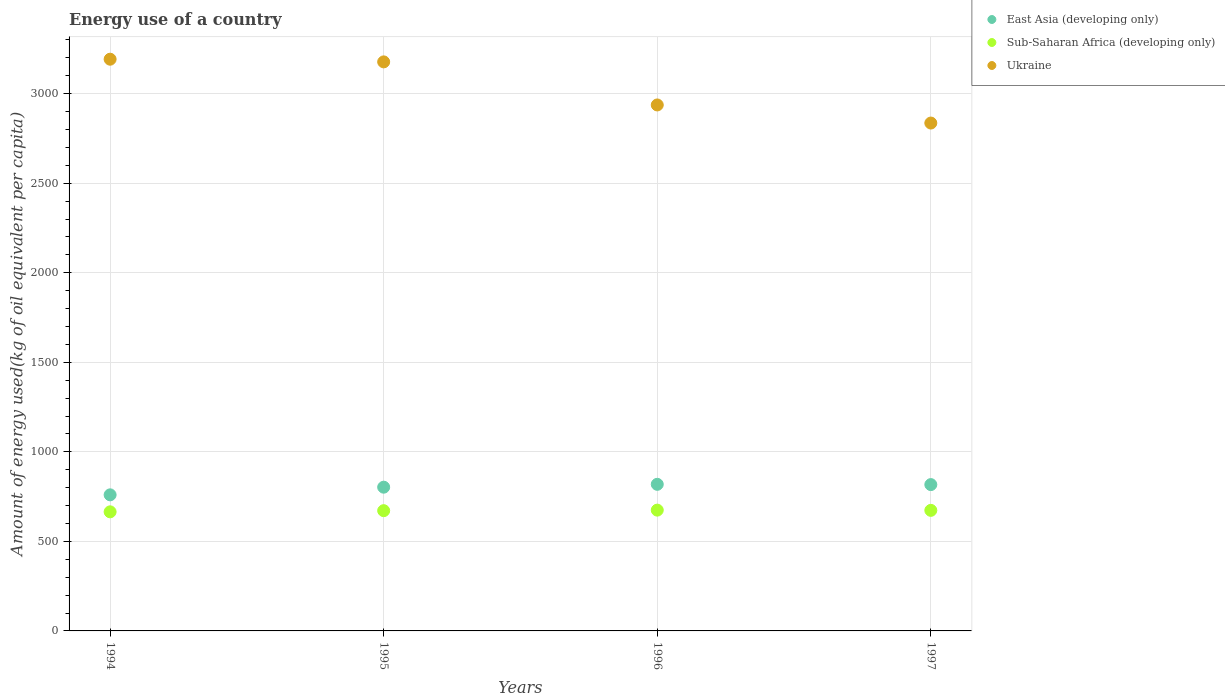Is the number of dotlines equal to the number of legend labels?
Make the answer very short. Yes. What is the amount of energy used in in Sub-Saharan Africa (developing only) in 1997?
Your answer should be very brief. 673.28. Across all years, what is the maximum amount of energy used in in East Asia (developing only)?
Keep it short and to the point. 818.7. Across all years, what is the minimum amount of energy used in in Ukraine?
Keep it short and to the point. 2836.21. In which year was the amount of energy used in in Sub-Saharan Africa (developing only) minimum?
Offer a very short reply. 1994. What is the total amount of energy used in in East Asia (developing only) in the graph?
Provide a short and direct response. 3198.47. What is the difference between the amount of energy used in in Ukraine in 1995 and that in 1996?
Provide a succinct answer. 240.54. What is the difference between the amount of energy used in in East Asia (developing only) in 1997 and the amount of energy used in in Ukraine in 1996?
Provide a short and direct response. -2120.14. What is the average amount of energy used in in Ukraine per year?
Your answer should be very brief. 3036.01. In the year 1997, what is the difference between the amount of energy used in in East Asia (developing only) and amount of energy used in in Ukraine?
Give a very brief answer. -2019.08. In how many years, is the amount of energy used in in Ukraine greater than 2400 kg?
Provide a short and direct response. 4. What is the ratio of the amount of energy used in in Sub-Saharan Africa (developing only) in 1996 to that in 1997?
Give a very brief answer. 1. Is the difference between the amount of energy used in in East Asia (developing only) in 1994 and 1995 greater than the difference between the amount of energy used in in Ukraine in 1994 and 1995?
Offer a terse response. No. What is the difference between the highest and the second highest amount of energy used in in East Asia (developing only)?
Keep it short and to the point. 1.58. What is the difference between the highest and the lowest amount of energy used in in Ukraine?
Your answer should be very brief. 356.53. Is the sum of the amount of energy used in in Sub-Saharan Africa (developing only) in 1994 and 1997 greater than the maximum amount of energy used in in East Asia (developing only) across all years?
Provide a succinct answer. Yes. Is it the case that in every year, the sum of the amount of energy used in in Ukraine and amount of energy used in in East Asia (developing only)  is greater than the amount of energy used in in Sub-Saharan Africa (developing only)?
Provide a succinct answer. Yes. Does the amount of energy used in in East Asia (developing only) monotonically increase over the years?
Offer a very short reply. No. How many dotlines are there?
Provide a short and direct response. 3. Are the values on the major ticks of Y-axis written in scientific E-notation?
Keep it short and to the point. No. Where does the legend appear in the graph?
Offer a very short reply. Top right. How many legend labels are there?
Offer a very short reply. 3. What is the title of the graph?
Your answer should be very brief. Energy use of a country. What is the label or title of the Y-axis?
Offer a very short reply. Amount of energy used(kg of oil equivalent per capita). What is the Amount of energy used(kg of oil equivalent per capita) of East Asia (developing only) in 1994?
Your answer should be very brief. 759.95. What is the Amount of energy used(kg of oil equivalent per capita) in Sub-Saharan Africa (developing only) in 1994?
Your response must be concise. 665.05. What is the Amount of energy used(kg of oil equivalent per capita) of Ukraine in 1994?
Offer a very short reply. 3192.74. What is the Amount of energy used(kg of oil equivalent per capita) of East Asia (developing only) in 1995?
Offer a terse response. 802.69. What is the Amount of energy used(kg of oil equivalent per capita) in Sub-Saharan Africa (developing only) in 1995?
Keep it short and to the point. 671.53. What is the Amount of energy used(kg of oil equivalent per capita) of Ukraine in 1995?
Provide a succinct answer. 3177.81. What is the Amount of energy used(kg of oil equivalent per capita) of East Asia (developing only) in 1996?
Your answer should be very brief. 818.7. What is the Amount of energy used(kg of oil equivalent per capita) of Sub-Saharan Africa (developing only) in 1996?
Offer a very short reply. 674.58. What is the Amount of energy used(kg of oil equivalent per capita) in Ukraine in 1996?
Your response must be concise. 2937.27. What is the Amount of energy used(kg of oil equivalent per capita) of East Asia (developing only) in 1997?
Ensure brevity in your answer.  817.13. What is the Amount of energy used(kg of oil equivalent per capita) of Sub-Saharan Africa (developing only) in 1997?
Make the answer very short. 673.28. What is the Amount of energy used(kg of oil equivalent per capita) in Ukraine in 1997?
Offer a very short reply. 2836.21. Across all years, what is the maximum Amount of energy used(kg of oil equivalent per capita) in East Asia (developing only)?
Give a very brief answer. 818.7. Across all years, what is the maximum Amount of energy used(kg of oil equivalent per capita) in Sub-Saharan Africa (developing only)?
Your answer should be very brief. 674.58. Across all years, what is the maximum Amount of energy used(kg of oil equivalent per capita) of Ukraine?
Provide a succinct answer. 3192.74. Across all years, what is the minimum Amount of energy used(kg of oil equivalent per capita) of East Asia (developing only)?
Give a very brief answer. 759.95. Across all years, what is the minimum Amount of energy used(kg of oil equivalent per capita) of Sub-Saharan Africa (developing only)?
Ensure brevity in your answer.  665.05. Across all years, what is the minimum Amount of energy used(kg of oil equivalent per capita) in Ukraine?
Ensure brevity in your answer.  2836.21. What is the total Amount of energy used(kg of oil equivalent per capita) of East Asia (developing only) in the graph?
Your response must be concise. 3198.47. What is the total Amount of energy used(kg of oil equivalent per capita) of Sub-Saharan Africa (developing only) in the graph?
Offer a very short reply. 2684.44. What is the total Amount of energy used(kg of oil equivalent per capita) in Ukraine in the graph?
Your answer should be very brief. 1.21e+04. What is the difference between the Amount of energy used(kg of oil equivalent per capita) of East Asia (developing only) in 1994 and that in 1995?
Your answer should be compact. -42.74. What is the difference between the Amount of energy used(kg of oil equivalent per capita) of Sub-Saharan Africa (developing only) in 1994 and that in 1995?
Your response must be concise. -6.49. What is the difference between the Amount of energy used(kg of oil equivalent per capita) in Ukraine in 1994 and that in 1995?
Offer a very short reply. 14.92. What is the difference between the Amount of energy used(kg of oil equivalent per capita) in East Asia (developing only) in 1994 and that in 1996?
Keep it short and to the point. -58.76. What is the difference between the Amount of energy used(kg of oil equivalent per capita) of Sub-Saharan Africa (developing only) in 1994 and that in 1996?
Your answer should be very brief. -9.53. What is the difference between the Amount of energy used(kg of oil equivalent per capita) of Ukraine in 1994 and that in 1996?
Your answer should be very brief. 255.47. What is the difference between the Amount of energy used(kg of oil equivalent per capita) of East Asia (developing only) in 1994 and that in 1997?
Provide a short and direct response. -57.18. What is the difference between the Amount of energy used(kg of oil equivalent per capita) of Sub-Saharan Africa (developing only) in 1994 and that in 1997?
Ensure brevity in your answer.  -8.23. What is the difference between the Amount of energy used(kg of oil equivalent per capita) of Ukraine in 1994 and that in 1997?
Your response must be concise. 356.53. What is the difference between the Amount of energy used(kg of oil equivalent per capita) in East Asia (developing only) in 1995 and that in 1996?
Your response must be concise. -16.01. What is the difference between the Amount of energy used(kg of oil equivalent per capita) in Sub-Saharan Africa (developing only) in 1995 and that in 1996?
Ensure brevity in your answer.  -3.04. What is the difference between the Amount of energy used(kg of oil equivalent per capita) in Ukraine in 1995 and that in 1996?
Ensure brevity in your answer.  240.54. What is the difference between the Amount of energy used(kg of oil equivalent per capita) in East Asia (developing only) in 1995 and that in 1997?
Provide a succinct answer. -14.44. What is the difference between the Amount of energy used(kg of oil equivalent per capita) of Sub-Saharan Africa (developing only) in 1995 and that in 1997?
Keep it short and to the point. -1.75. What is the difference between the Amount of energy used(kg of oil equivalent per capita) of Ukraine in 1995 and that in 1997?
Provide a succinct answer. 341.61. What is the difference between the Amount of energy used(kg of oil equivalent per capita) in East Asia (developing only) in 1996 and that in 1997?
Provide a succinct answer. 1.58. What is the difference between the Amount of energy used(kg of oil equivalent per capita) of Sub-Saharan Africa (developing only) in 1996 and that in 1997?
Give a very brief answer. 1.3. What is the difference between the Amount of energy used(kg of oil equivalent per capita) in Ukraine in 1996 and that in 1997?
Give a very brief answer. 101.06. What is the difference between the Amount of energy used(kg of oil equivalent per capita) in East Asia (developing only) in 1994 and the Amount of energy used(kg of oil equivalent per capita) in Sub-Saharan Africa (developing only) in 1995?
Your response must be concise. 88.42. What is the difference between the Amount of energy used(kg of oil equivalent per capita) in East Asia (developing only) in 1994 and the Amount of energy used(kg of oil equivalent per capita) in Ukraine in 1995?
Provide a short and direct response. -2417.86. What is the difference between the Amount of energy used(kg of oil equivalent per capita) in Sub-Saharan Africa (developing only) in 1994 and the Amount of energy used(kg of oil equivalent per capita) in Ukraine in 1995?
Give a very brief answer. -2512.77. What is the difference between the Amount of energy used(kg of oil equivalent per capita) of East Asia (developing only) in 1994 and the Amount of energy used(kg of oil equivalent per capita) of Sub-Saharan Africa (developing only) in 1996?
Offer a terse response. 85.37. What is the difference between the Amount of energy used(kg of oil equivalent per capita) in East Asia (developing only) in 1994 and the Amount of energy used(kg of oil equivalent per capita) in Ukraine in 1996?
Keep it short and to the point. -2177.32. What is the difference between the Amount of energy used(kg of oil equivalent per capita) of Sub-Saharan Africa (developing only) in 1994 and the Amount of energy used(kg of oil equivalent per capita) of Ukraine in 1996?
Offer a terse response. -2272.22. What is the difference between the Amount of energy used(kg of oil equivalent per capita) of East Asia (developing only) in 1994 and the Amount of energy used(kg of oil equivalent per capita) of Sub-Saharan Africa (developing only) in 1997?
Provide a succinct answer. 86.67. What is the difference between the Amount of energy used(kg of oil equivalent per capita) in East Asia (developing only) in 1994 and the Amount of energy used(kg of oil equivalent per capita) in Ukraine in 1997?
Give a very brief answer. -2076.26. What is the difference between the Amount of energy used(kg of oil equivalent per capita) of Sub-Saharan Africa (developing only) in 1994 and the Amount of energy used(kg of oil equivalent per capita) of Ukraine in 1997?
Your response must be concise. -2171.16. What is the difference between the Amount of energy used(kg of oil equivalent per capita) in East Asia (developing only) in 1995 and the Amount of energy used(kg of oil equivalent per capita) in Sub-Saharan Africa (developing only) in 1996?
Offer a very short reply. 128.11. What is the difference between the Amount of energy used(kg of oil equivalent per capita) of East Asia (developing only) in 1995 and the Amount of energy used(kg of oil equivalent per capita) of Ukraine in 1996?
Keep it short and to the point. -2134.58. What is the difference between the Amount of energy used(kg of oil equivalent per capita) in Sub-Saharan Africa (developing only) in 1995 and the Amount of energy used(kg of oil equivalent per capita) in Ukraine in 1996?
Ensure brevity in your answer.  -2265.74. What is the difference between the Amount of energy used(kg of oil equivalent per capita) in East Asia (developing only) in 1995 and the Amount of energy used(kg of oil equivalent per capita) in Sub-Saharan Africa (developing only) in 1997?
Offer a terse response. 129.41. What is the difference between the Amount of energy used(kg of oil equivalent per capita) in East Asia (developing only) in 1995 and the Amount of energy used(kg of oil equivalent per capita) in Ukraine in 1997?
Give a very brief answer. -2033.52. What is the difference between the Amount of energy used(kg of oil equivalent per capita) of Sub-Saharan Africa (developing only) in 1995 and the Amount of energy used(kg of oil equivalent per capita) of Ukraine in 1997?
Your answer should be very brief. -2164.67. What is the difference between the Amount of energy used(kg of oil equivalent per capita) of East Asia (developing only) in 1996 and the Amount of energy used(kg of oil equivalent per capita) of Sub-Saharan Africa (developing only) in 1997?
Your answer should be compact. 145.43. What is the difference between the Amount of energy used(kg of oil equivalent per capita) of East Asia (developing only) in 1996 and the Amount of energy used(kg of oil equivalent per capita) of Ukraine in 1997?
Ensure brevity in your answer.  -2017.5. What is the difference between the Amount of energy used(kg of oil equivalent per capita) of Sub-Saharan Africa (developing only) in 1996 and the Amount of energy used(kg of oil equivalent per capita) of Ukraine in 1997?
Your answer should be compact. -2161.63. What is the average Amount of energy used(kg of oil equivalent per capita) in East Asia (developing only) per year?
Your answer should be very brief. 799.62. What is the average Amount of energy used(kg of oil equivalent per capita) of Sub-Saharan Africa (developing only) per year?
Offer a very short reply. 671.11. What is the average Amount of energy used(kg of oil equivalent per capita) of Ukraine per year?
Your answer should be compact. 3036.01. In the year 1994, what is the difference between the Amount of energy used(kg of oil equivalent per capita) in East Asia (developing only) and Amount of energy used(kg of oil equivalent per capita) in Sub-Saharan Africa (developing only)?
Your answer should be compact. 94.9. In the year 1994, what is the difference between the Amount of energy used(kg of oil equivalent per capita) of East Asia (developing only) and Amount of energy used(kg of oil equivalent per capita) of Ukraine?
Ensure brevity in your answer.  -2432.79. In the year 1994, what is the difference between the Amount of energy used(kg of oil equivalent per capita) in Sub-Saharan Africa (developing only) and Amount of energy used(kg of oil equivalent per capita) in Ukraine?
Ensure brevity in your answer.  -2527.69. In the year 1995, what is the difference between the Amount of energy used(kg of oil equivalent per capita) of East Asia (developing only) and Amount of energy used(kg of oil equivalent per capita) of Sub-Saharan Africa (developing only)?
Offer a very short reply. 131.16. In the year 1995, what is the difference between the Amount of energy used(kg of oil equivalent per capita) of East Asia (developing only) and Amount of energy used(kg of oil equivalent per capita) of Ukraine?
Your answer should be compact. -2375.12. In the year 1995, what is the difference between the Amount of energy used(kg of oil equivalent per capita) of Sub-Saharan Africa (developing only) and Amount of energy used(kg of oil equivalent per capita) of Ukraine?
Make the answer very short. -2506.28. In the year 1996, what is the difference between the Amount of energy used(kg of oil equivalent per capita) of East Asia (developing only) and Amount of energy used(kg of oil equivalent per capita) of Sub-Saharan Africa (developing only)?
Give a very brief answer. 144.13. In the year 1996, what is the difference between the Amount of energy used(kg of oil equivalent per capita) in East Asia (developing only) and Amount of energy used(kg of oil equivalent per capita) in Ukraine?
Provide a succinct answer. -2118.57. In the year 1996, what is the difference between the Amount of energy used(kg of oil equivalent per capita) of Sub-Saharan Africa (developing only) and Amount of energy used(kg of oil equivalent per capita) of Ukraine?
Your answer should be compact. -2262.69. In the year 1997, what is the difference between the Amount of energy used(kg of oil equivalent per capita) of East Asia (developing only) and Amount of energy used(kg of oil equivalent per capita) of Sub-Saharan Africa (developing only)?
Provide a succinct answer. 143.85. In the year 1997, what is the difference between the Amount of energy used(kg of oil equivalent per capita) in East Asia (developing only) and Amount of energy used(kg of oil equivalent per capita) in Ukraine?
Offer a very short reply. -2019.08. In the year 1997, what is the difference between the Amount of energy used(kg of oil equivalent per capita) in Sub-Saharan Africa (developing only) and Amount of energy used(kg of oil equivalent per capita) in Ukraine?
Offer a terse response. -2162.93. What is the ratio of the Amount of energy used(kg of oil equivalent per capita) of East Asia (developing only) in 1994 to that in 1995?
Give a very brief answer. 0.95. What is the ratio of the Amount of energy used(kg of oil equivalent per capita) of Sub-Saharan Africa (developing only) in 1994 to that in 1995?
Offer a very short reply. 0.99. What is the ratio of the Amount of energy used(kg of oil equivalent per capita) of East Asia (developing only) in 1994 to that in 1996?
Offer a very short reply. 0.93. What is the ratio of the Amount of energy used(kg of oil equivalent per capita) in Sub-Saharan Africa (developing only) in 1994 to that in 1996?
Provide a short and direct response. 0.99. What is the ratio of the Amount of energy used(kg of oil equivalent per capita) of Ukraine in 1994 to that in 1996?
Offer a terse response. 1.09. What is the ratio of the Amount of energy used(kg of oil equivalent per capita) of East Asia (developing only) in 1994 to that in 1997?
Your response must be concise. 0.93. What is the ratio of the Amount of energy used(kg of oil equivalent per capita) of Sub-Saharan Africa (developing only) in 1994 to that in 1997?
Your response must be concise. 0.99. What is the ratio of the Amount of energy used(kg of oil equivalent per capita) of Ukraine in 1994 to that in 1997?
Make the answer very short. 1.13. What is the ratio of the Amount of energy used(kg of oil equivalent per capita) in East Asia (developing only) in 1995 to that in 1996?
Provide a succinct answer. 0.98. What is the ratio of the Amount of energy used(kg of oil equivalent per capita) in Sub-Saharan Africa (developing only) in 1995 to that in 1996?
Provide a short and direct response. 1. What is the ratio of the Amount of energy used(kg of oil equivalent per capita) in Ukraine in 1995 to that in 1996?
Ensure brevity in your answer.  1.08. What is the ratio of the Amount of energy used(kg of oil equivalent per capita) of East Asia (developing only) in 1995 to that in 1997?
Your answer should be compact. 0.98. What is the ratio of the Amount of energy used(kg of oil equivalent per capita) in Sub-Saharan Africa (developing only) in 1995 to that in 1997?
Provide a short and direct response. 1. What is the ratio of the Amount of energy used(kg of oil equivalent per capita) of Ukraine in 1995 to that in 1997?
Provide a short and direct response. 1.12. What is the ratio of the Amount of energy used(kg of oil equivalent per capita) of Ukraine in 1996 to that in 1997?
Make the answer very short. 1.04. What is the difference between the highest and the second highest Amount of energy used(kg of oil equivalent per capita) of East Asia (developing only)?
Keep it short and to the point. 1.58. What is the difference between the highest and the second highest Amount of energy used(kg of oil equivalent per capita) in Sub-Saharan Africa (developing only)?
Provide a short and direct response. 1.3. What is the difference between the highest and the second highest Amount of energy used(kg of oil equivalent per capita) in Ukraine?
Offer a terse response. 14.92. What is the difference between the highest and the lowest Amount of energy used(kg of oil equivalent per capita) of East Asia (developing only)?
Offer a very short reply. 58.76. What is the difference between the highest and the lowest Amount of energy used(kg of oil equivalent per capita) in Sub-Saharan Africa (developing only)?
Give a very brief answer. 9.53. What is the difference between the highest and the lowest Amount of energy used(kg of oil equivalent per capita) of Ukraine?
Give a very brief answer. 356.53. 